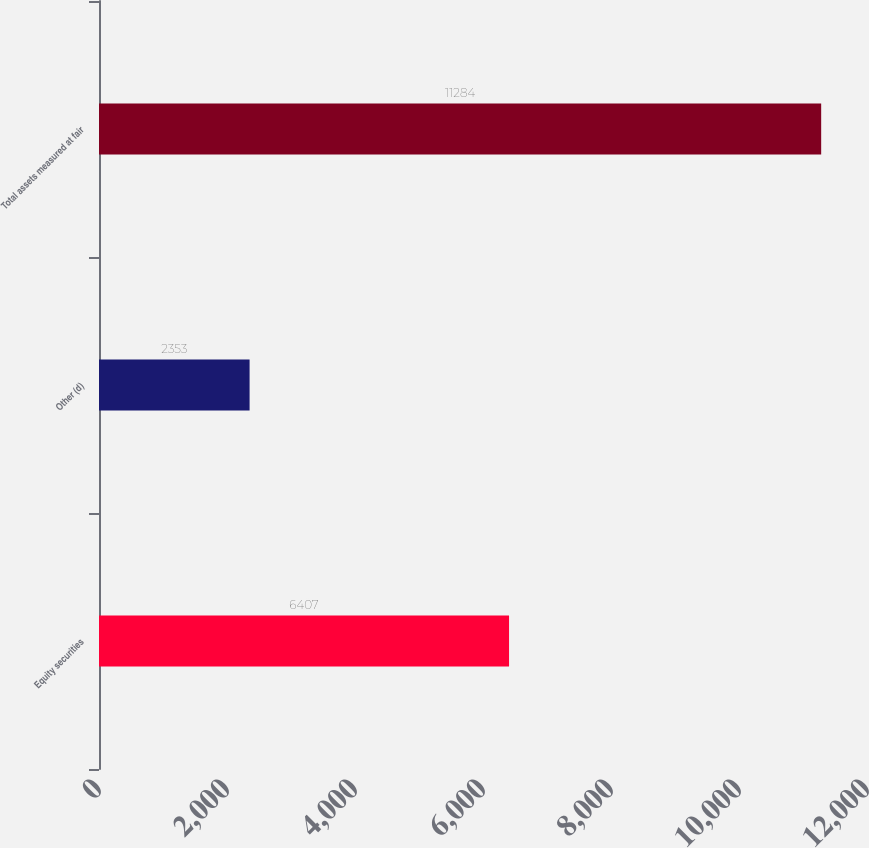Convert chart to OTSL. <chart><loc_0><loc_0><loc_500><loc_500><bar_chart><fcel>Equity securities<fcel>Other (d)<fcel>Total assets measured at fair<nl><fcel>6407<fcel>2353<fcel>11284<nl></chart> 